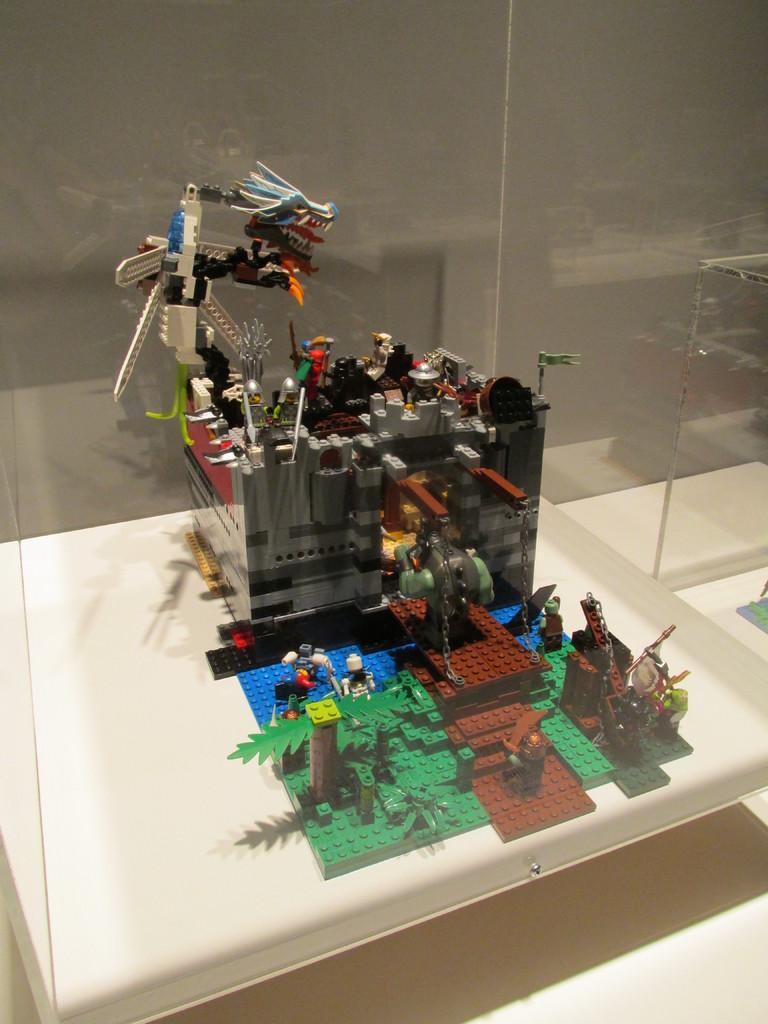Could you give a brief overview of what you see in this image? In the center of the image there is a lego on the white color surface. In the background of the image there is a wall. 